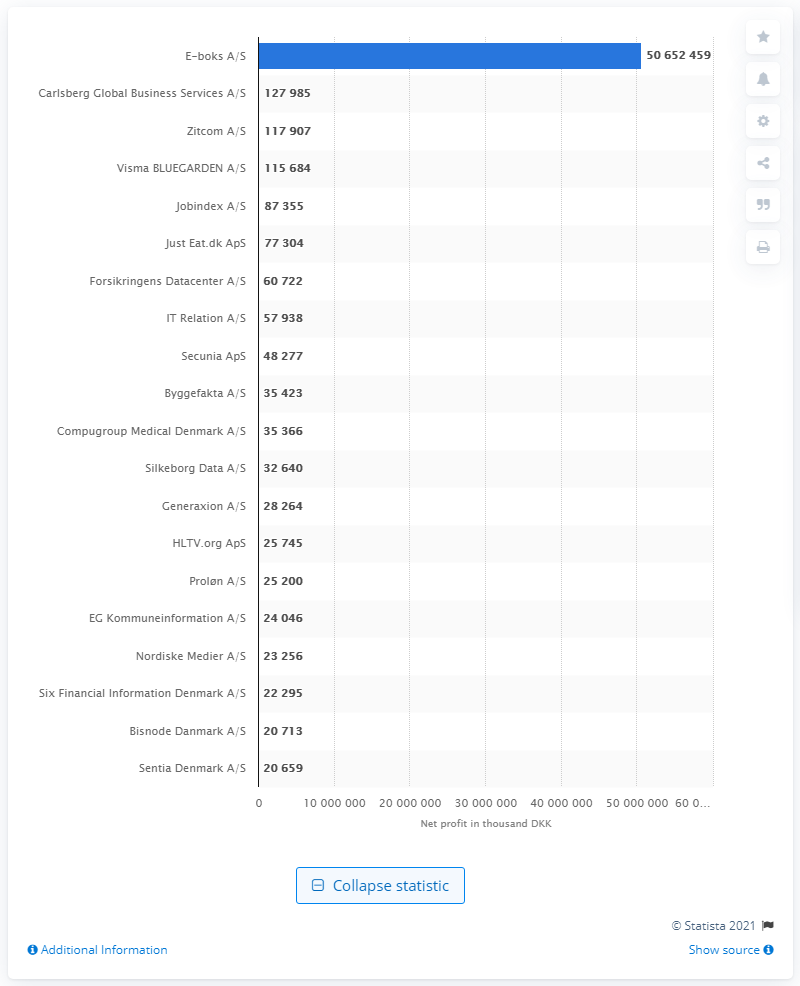Mention a couple of crucial points in this snapshot. E-boks A/S was the most profitable company in the information service industry in Denmark as of March 2021. Carlsberg Global Business Services A/S's net profit was 127,985 Danish kroner. E-boks A/S generated a net profit of 50,652,459 Danish kroner in the most recent fiscal year. 